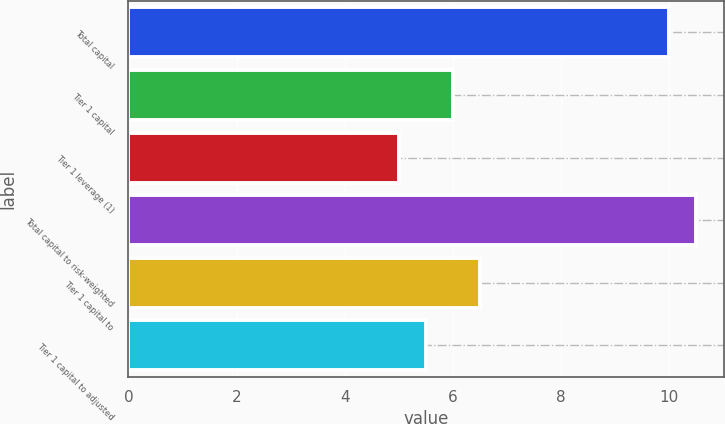<chart> <loc_0><loc_0><loc_500><loc_500><bar_chart><fcel>Total capital<fcel>Tier 1 capital<fcel>Tier 1 leverage (1)<fcel>Total capital to risk-weighted<fcel>Tier 1 capital to<fcel>Tier 1 capital to adjusted<nl><fcel>10<fcel>6<fcel>5<fcel>10.5<fcel>6.5<fcel>5.5<nl></chart> 